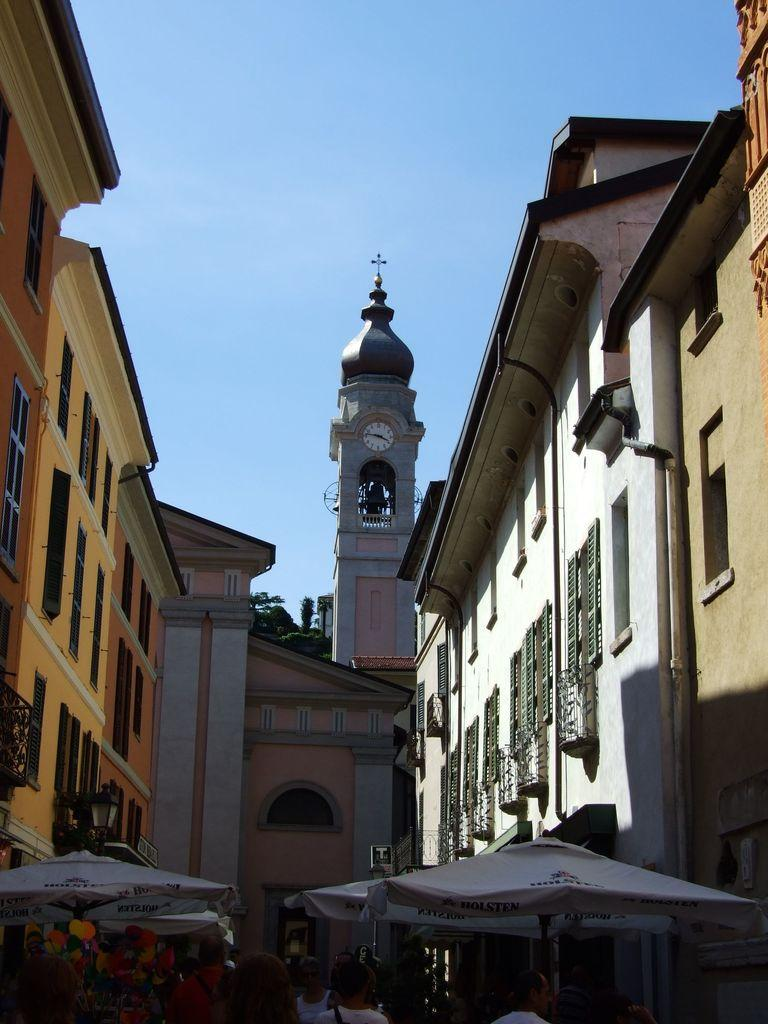What type of temporary shelters can be seen in the image? There are tents in the image. Are there any people present in the image? Yes, there are people in the image. What can be seen in the background of the image? There are buildings and the sky visible in the background of the image. What type of chain is being used by the tramp in the image? There is no tramp or chain present in the image. 